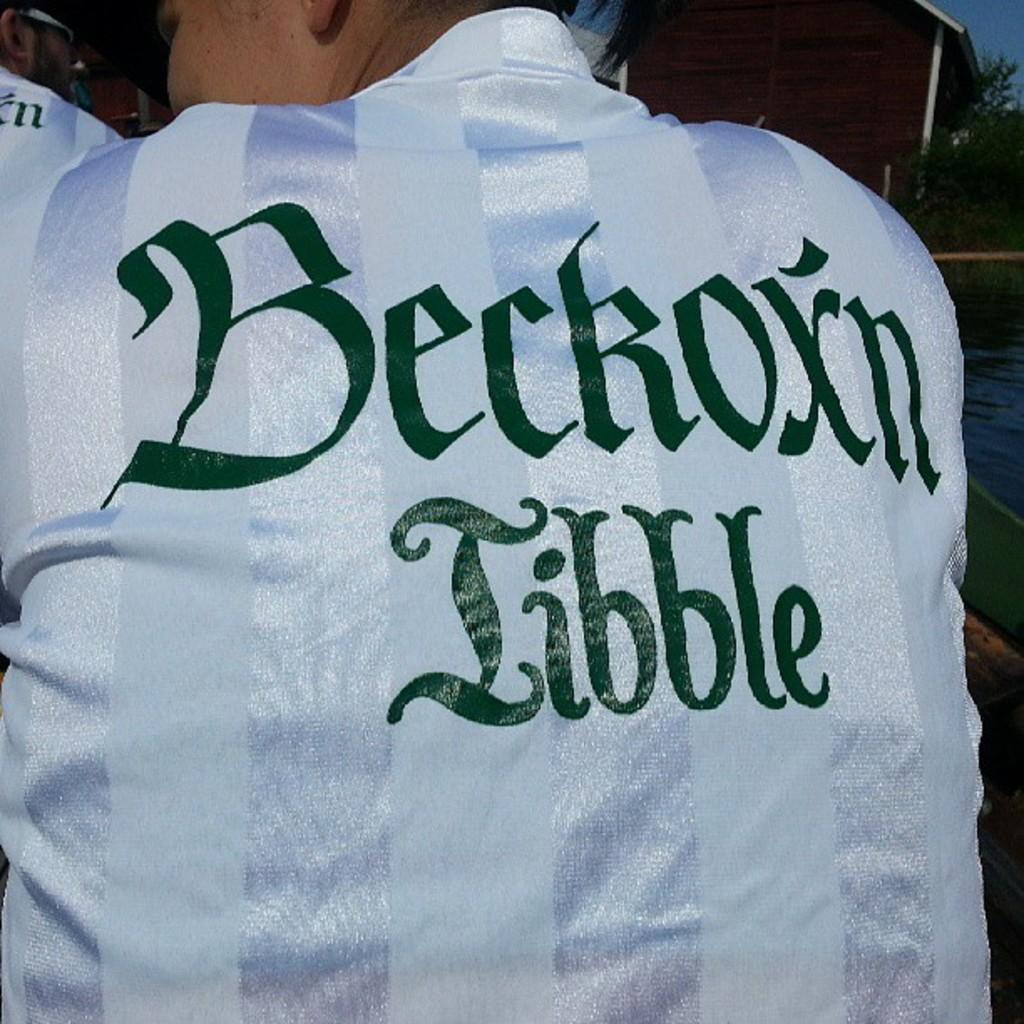Provide a one-sentence caption for the provided image. A man's jacket sports the phrase Beckoxn Tibble on the back of it. 